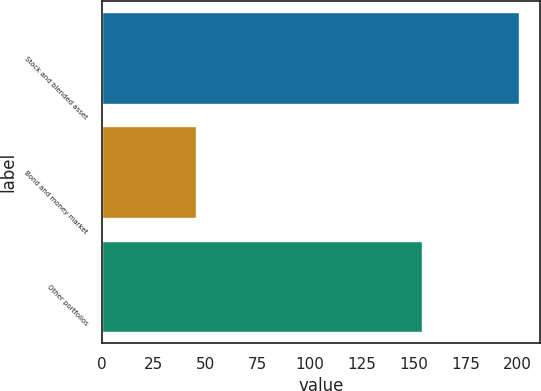<chart> <loc_0><loc_0><loc_500><loc_500><bar_chart><fcel>Stock and blended asset<fcel>Bond and money market<fcel>Other portfolios<nl><fcel>200.6<fcel>45.4<fcel>154<nl></chart> 